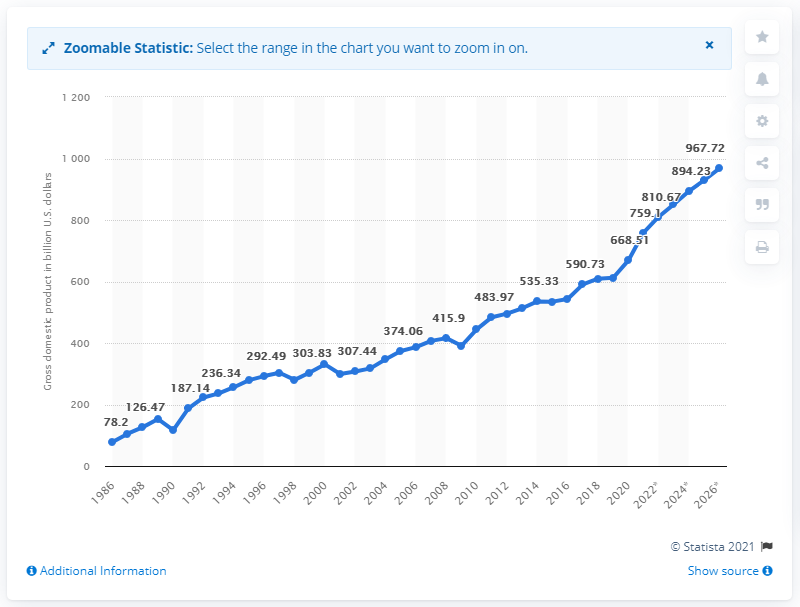How does Taiwan's GDP growth from 2015 to 2020 compare to earlier years? From 2015 to 2020, Taiwan's GDP saw a consistent increase, growing from 533.53 billion U.S. dollars in 2015 to 668.51 billion in 2020. This period exhibits a more gradual growth compared to the rapid increases seen in earlier decades, such as the 1990s. 